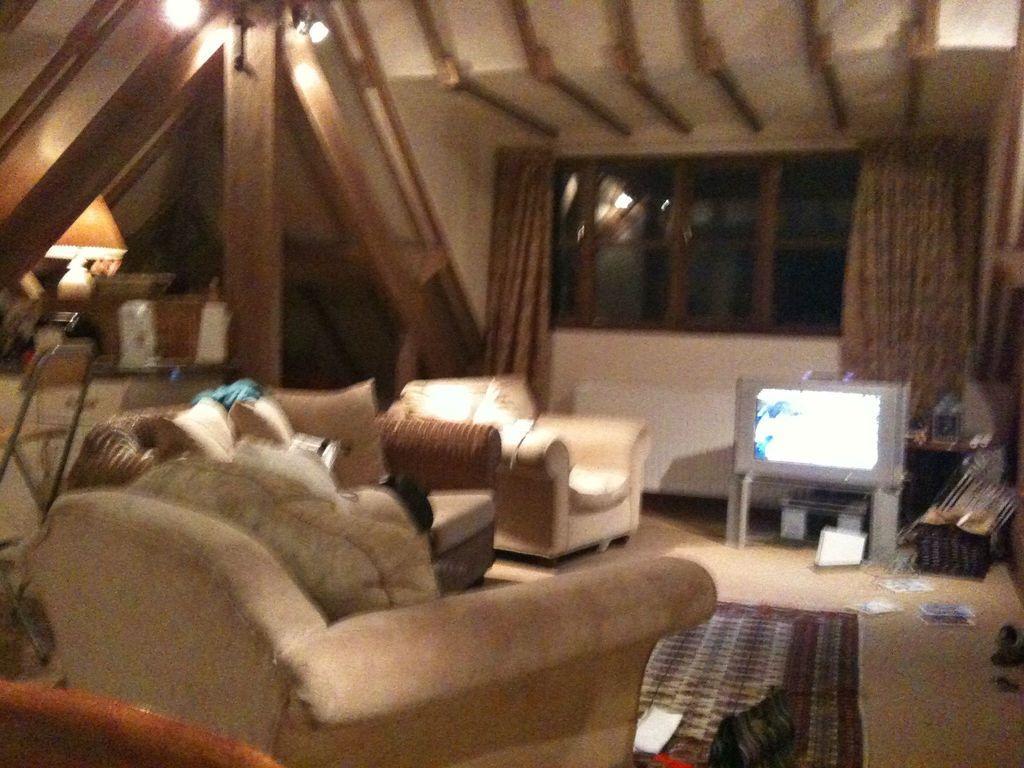Describe this image in one or two sentences. This is the blurred picture of a room where we have sofa, door mat, television, and a desk on which some things are placed. 